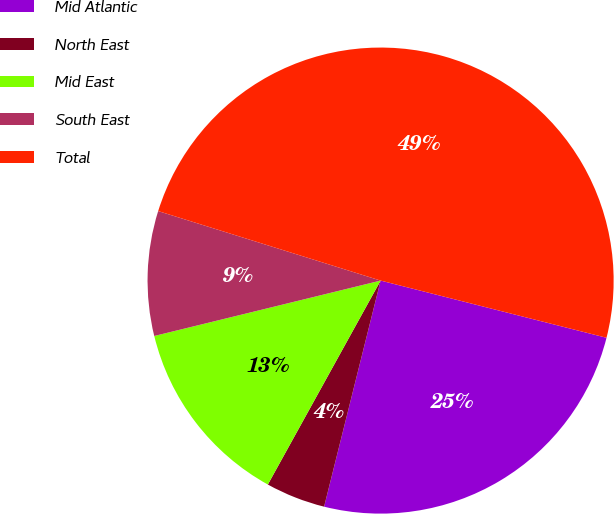Convert chart to OTSL. <chart><loc_0><loc_0><loc_500><loc_500><pie_chart><fcel>Mid Atlantic<fcel>North East<fcel>Mid East<fcel>South East<fcel>Total<nl><fcel>24.95%<fcel>4.14%<fcel>13.14%<fcel>8.64%<fcel>49.12%<nl></chart> 